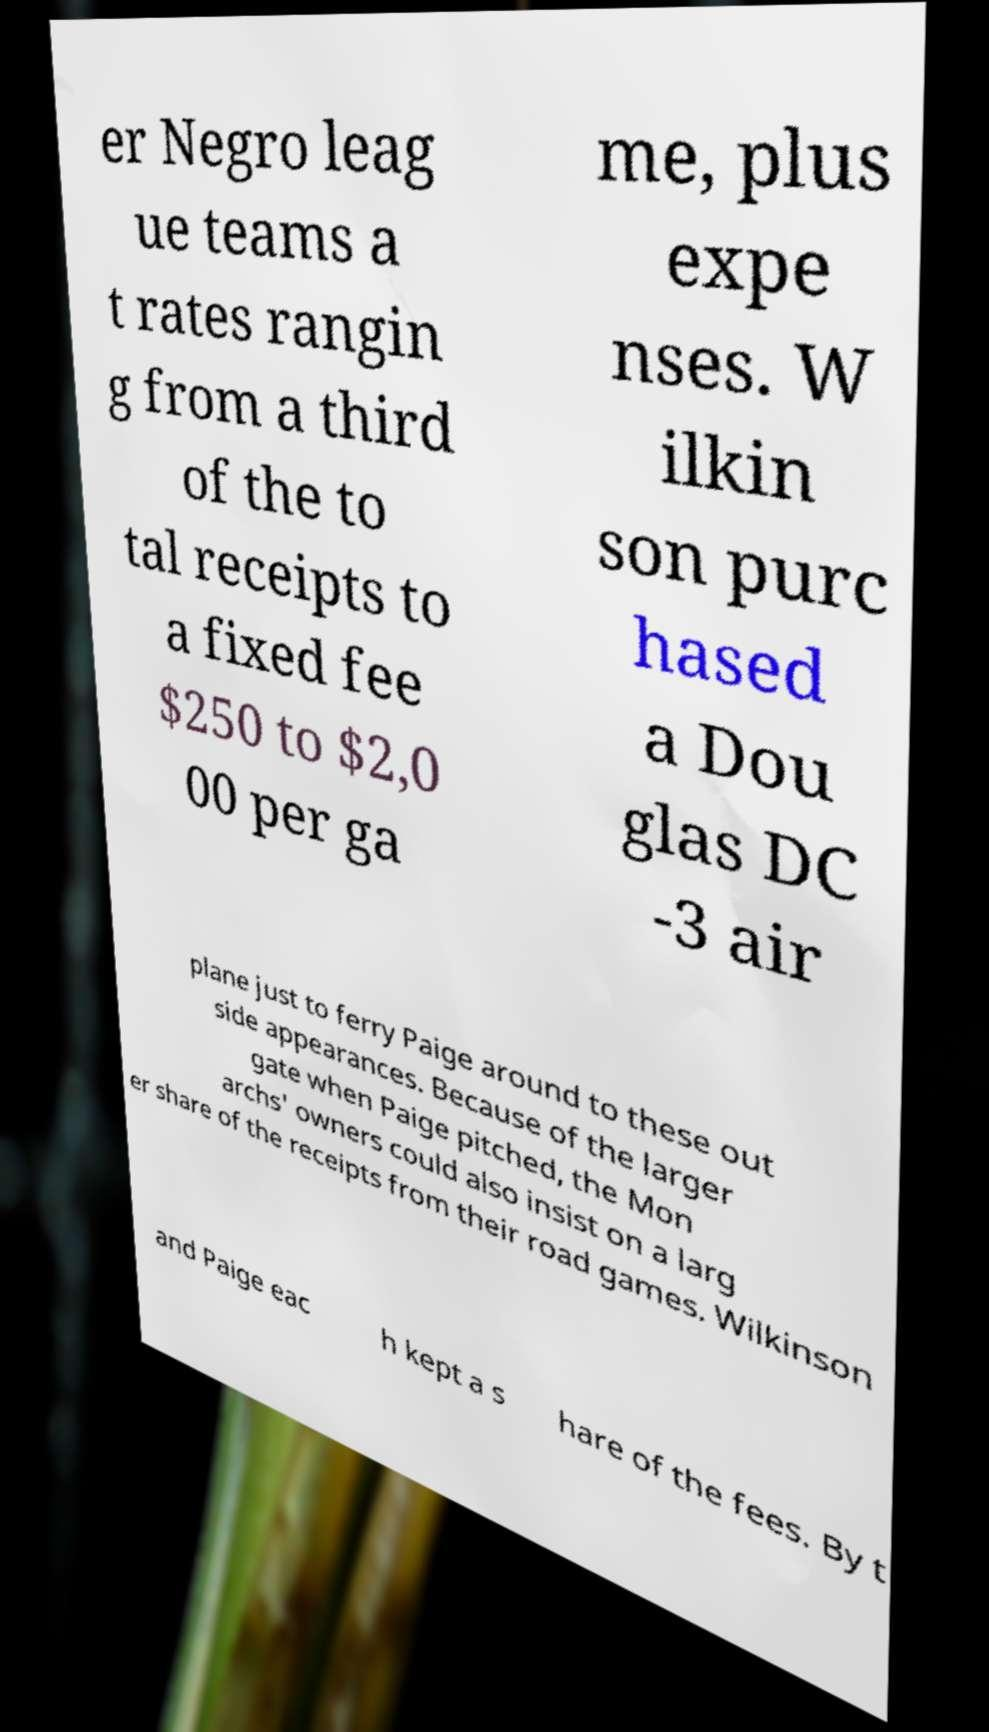What messages or text are displayed in this image? I need them in a readable, typed format. er Negro leag ue teams a t rates rangin g from a third of the to tal receipts to a fixed fee $250 to $2,0 00 per ga me, plus expe nses. W ilkin son purc hased a Dou glas DC -3 air plane just to ferry Paige around to these out side appearances. Because of the larger gate when Paige pitched, the Mon archs' owners could also insist on a larg er share of the receipts from their road games. Wilkinson and Paige eac h kept a s hare of the fees. By t 